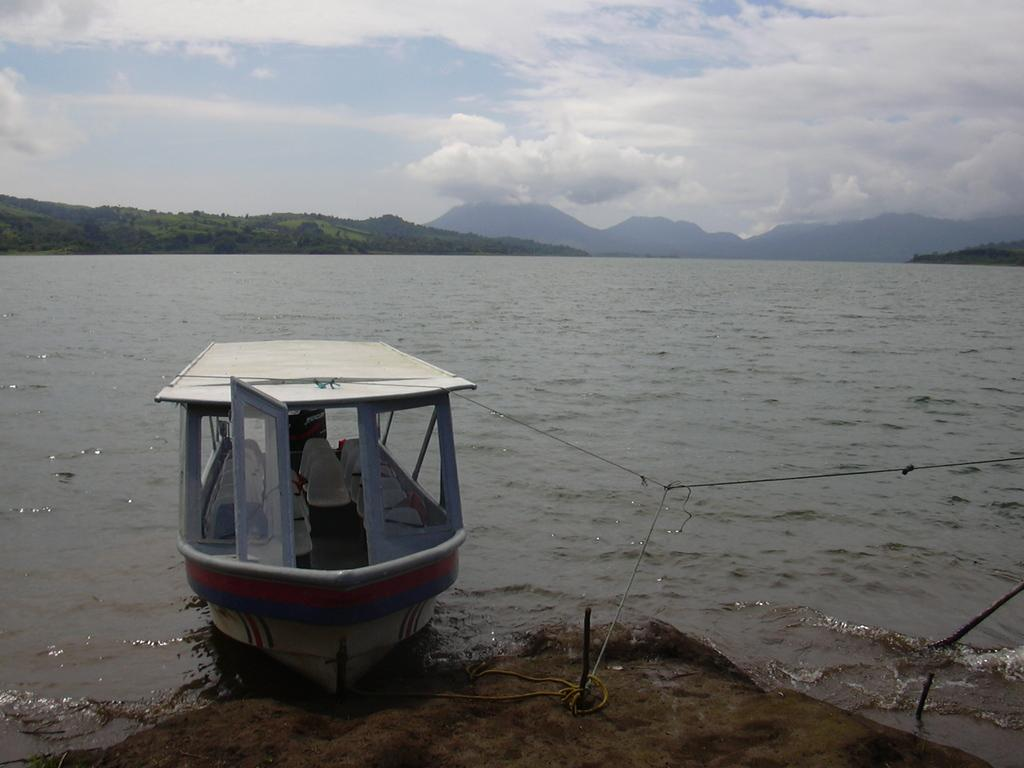What is the main subject of the image? The main subject of the image is a boat. Where is the boat located in the image? The boat is on the bank of a river. What can be seen in the background of the image? There are mountains in the background of the image. What is visible in the sky in the image? The sky is visible in the image, and clouds are present. What type of button is the monkey playing with on the boat? There is no monkey or button present in the image; it features a boat on the bank of a river with mountains in the background and clouds in the sky. 